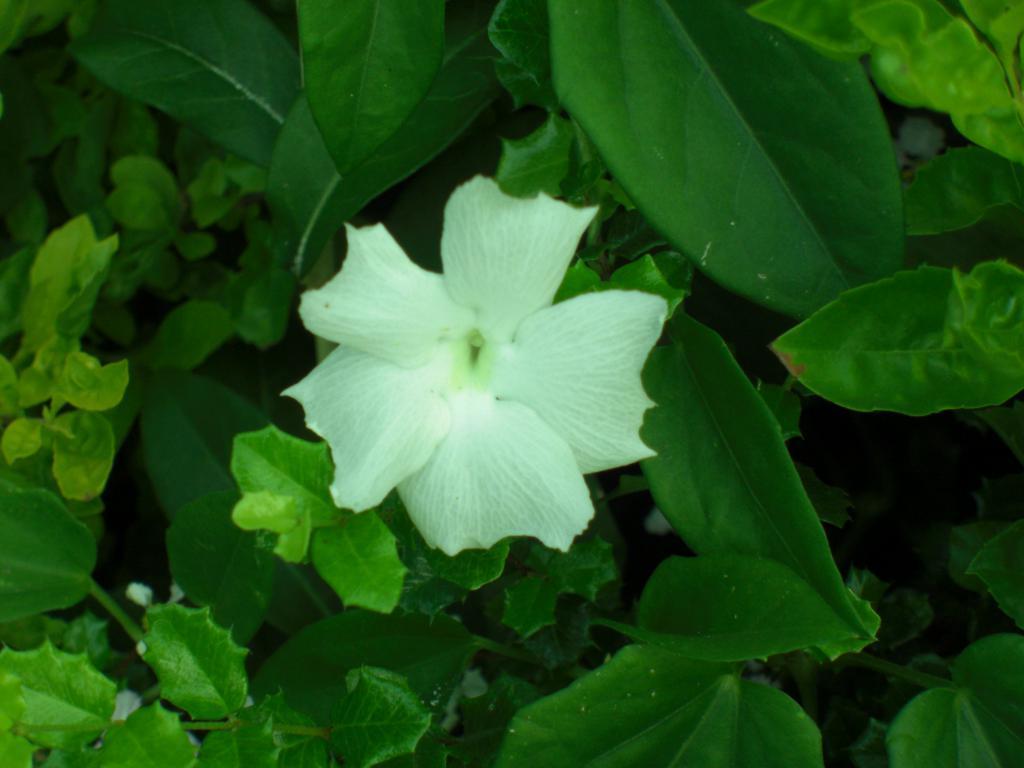Can you describe this image briefly? In this picture we can see a white color flower and some leaves here. 